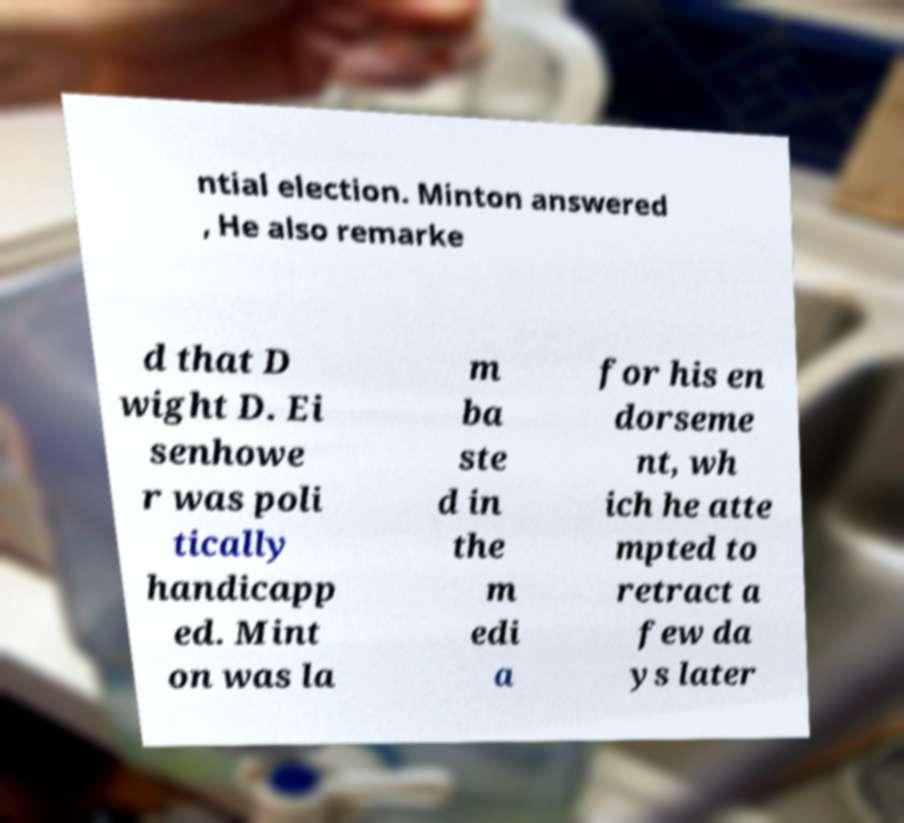Could you extract and type out the text from this image? ntial election. Minton answered , He also remarke d that D wight D. Ei senhowe r was poli tically handicapp ed. Mint on was la m ba ste d in the m edi a for his en dorseme nt, wh ich he atte mpted to retract a few da ys later 